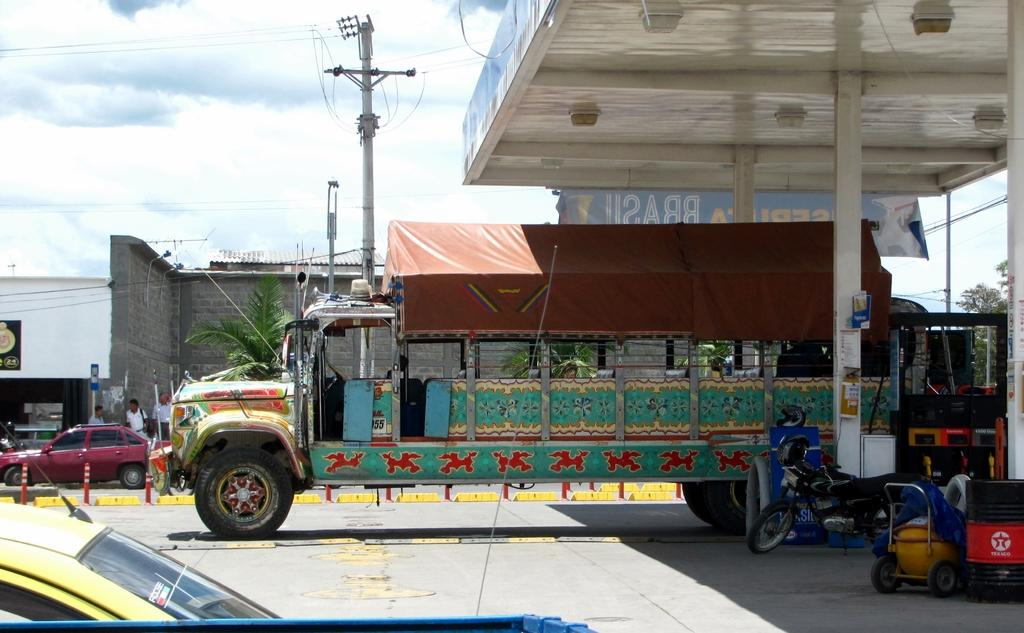What can be seen on the road in the image? There are vehicles on the road in the image. What is located on the right side of the image? There is a petrol pump on the right side of the image. What can be seen in the background of the image? There are poles with wires, buildings, and traffic poles in the background of the image. What is visible in the sky in the image? The sky is visible in the background of the image. What is the opinion of the rock on the traffic poles in the image? There is no rock present in the image, and therefore no opinion can be attributed to it. 